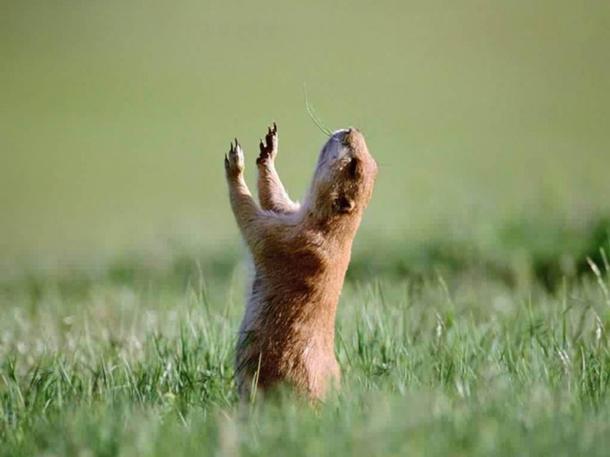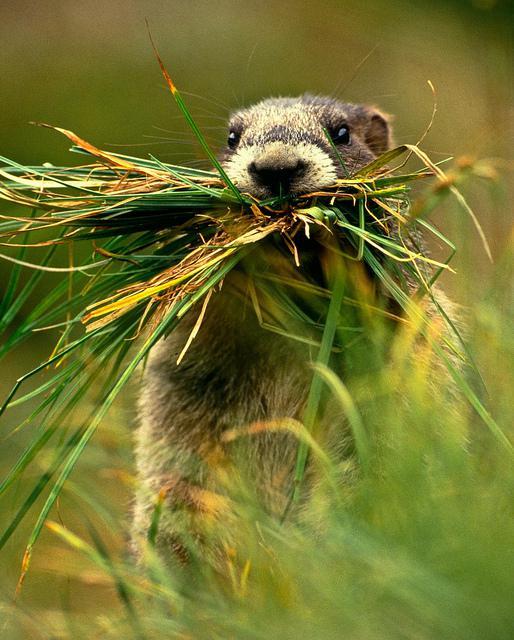The first image is the image on the left, the second image is the image on the right. For the images displayed, is the sentence "All marmots shown are standing up on their hind legs, and one image shows a single marmot facing forward." factually correct? Answer yes or no. Yes. 